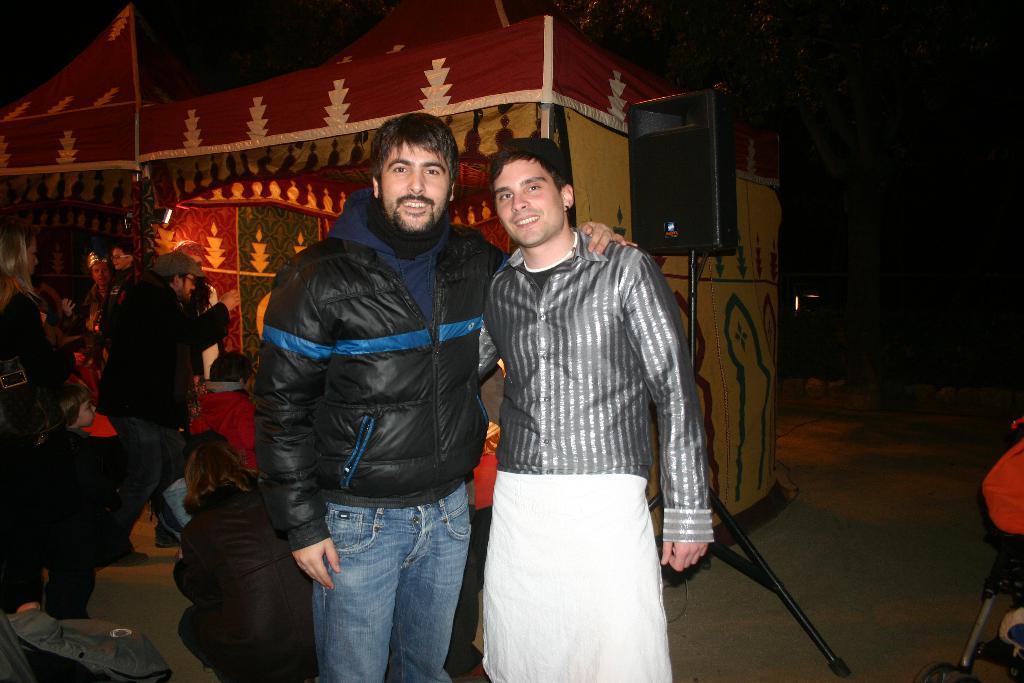Can you describe this image briefly? In the center of the image we can see two people are standing and they are smiling. In the background there is a tent, speaker, few people and a few other objects. 